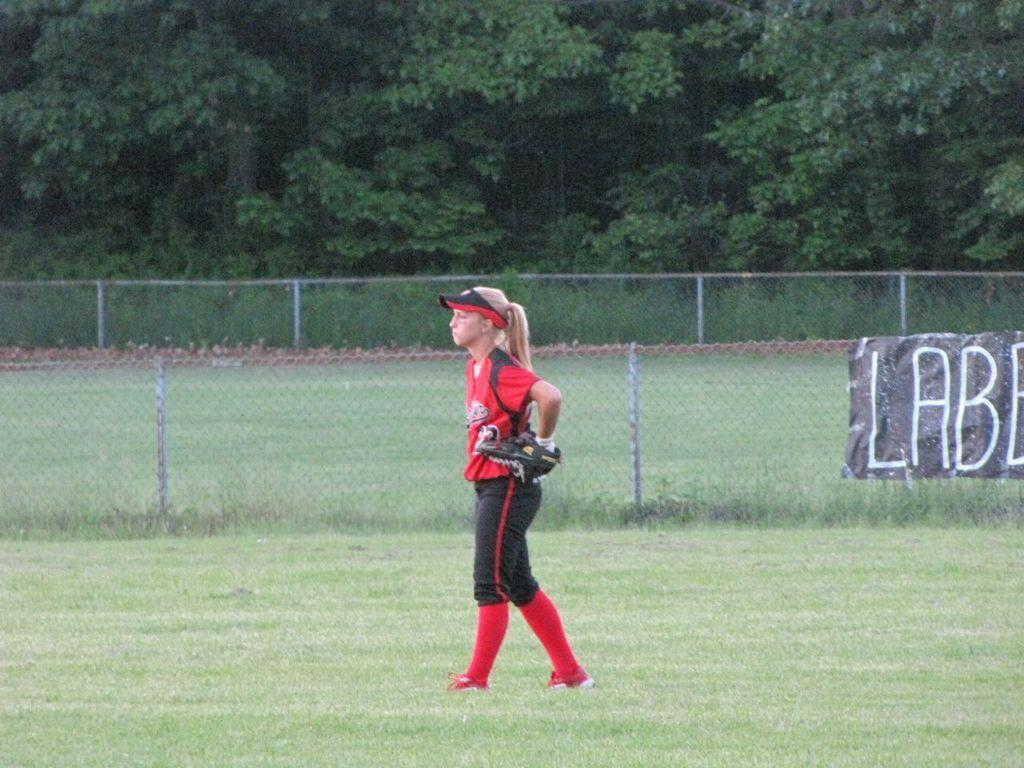<image>
Give a short and clear explanation of the subsequent image. A player wearing a red uniform stands near a sign that says "LABE" 